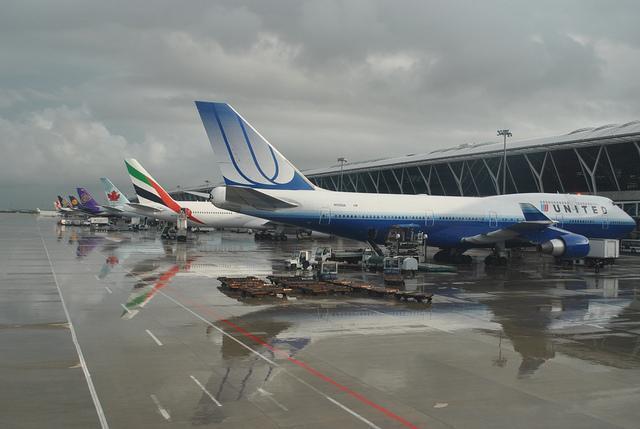How many people are in this image?
Give a very brief answer. 0. How many airplanes can be seen?
Give a very brief answer. 2. How many knives are visible in the picture?
Give a very brief answer. 0. 